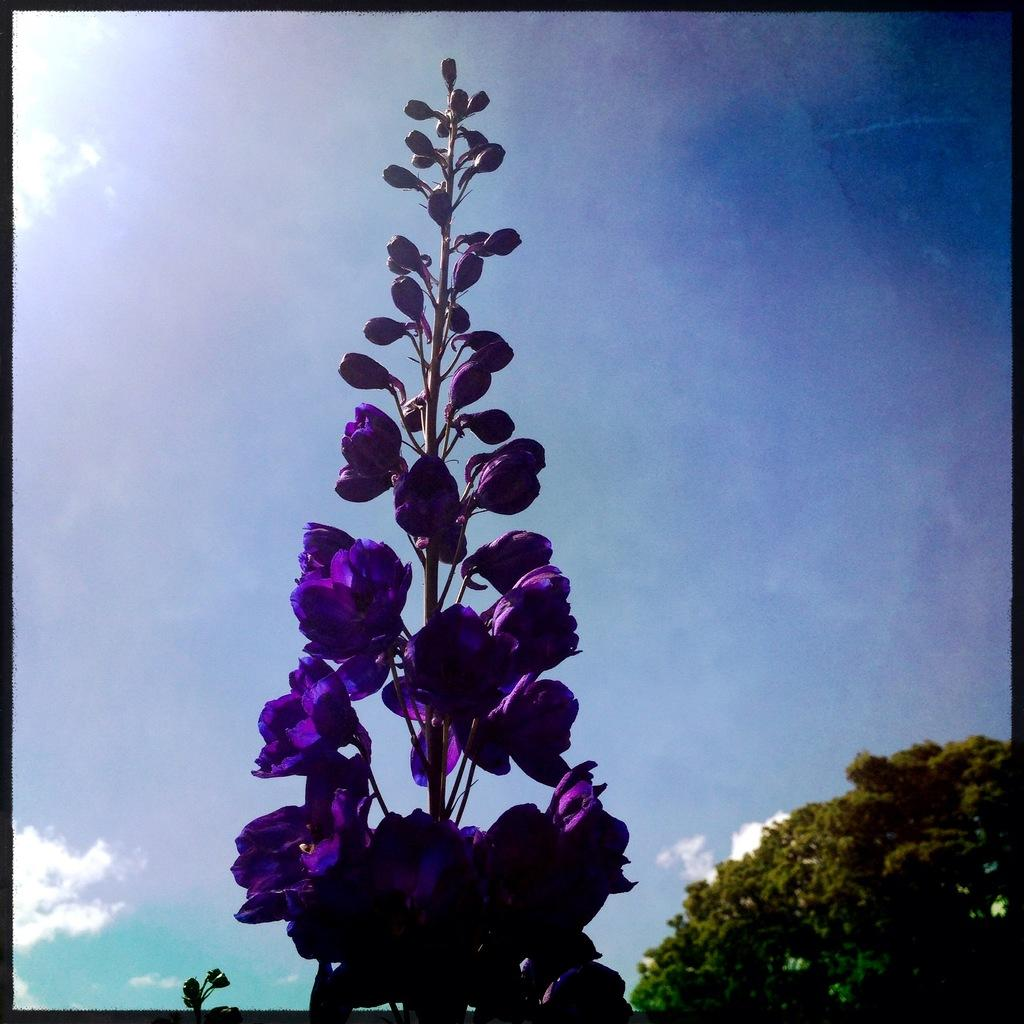What is located in the foreground of the image? There is a plant in the foreground of the image. What can be observed on the plant? The plant has flowers on it. What is visible in the background of the image? There is a tree in the background of the image. How would you describe the sky in the image? The sky is cloudy in the image. Can you tell me how many geese are standing on the thing in the image? There are no geese or things visible in the image; it features a plant with flowers and a tree in the background. 